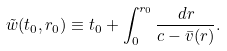<formula> <loc_0><loc_0><loc_500><loc_500>\tilde { w } ( t _ { 0 } , r _ { 0 } ) \equiv t _ { 0 } + \int _ { 0 } ^ { r _ { 0 } } \frac { d r } { c - \bar { v } ( r ) } .</formula> 